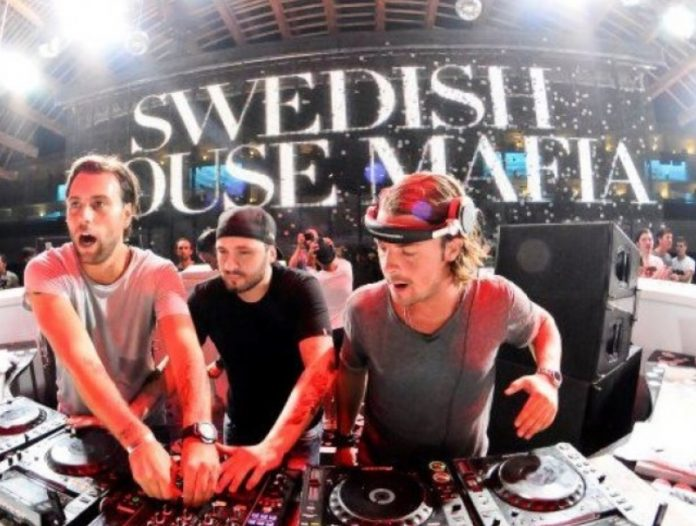Based on the signage visible in the market, what languages are likely spoken in this city, and what does this suggest about its cultural diversity? The market signage displays text in various languages, indicating that multiple languages are spoken in this city. This suggests the city is a cultural melting pot with a rich diversity of ethnic groups living and interacting with one another. The presence of multiple languages reflects the city's inclusive nature and the market's intent to cater to a diverse clientele. This linguistic variety highlights the city's dynamic and welcoming atmosphere, likely influenced by a history of migration and cultural exchange. 